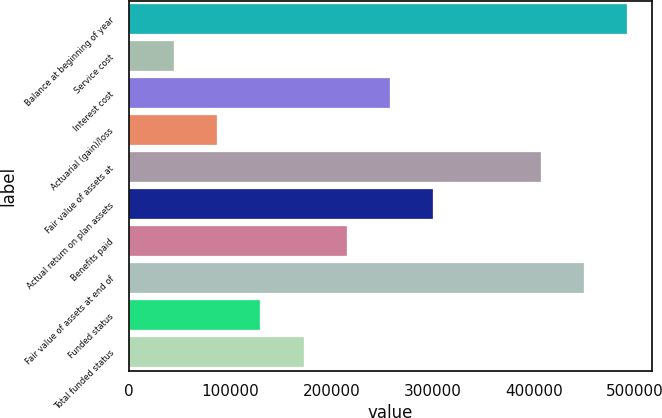Convert chart to OTSL. <chart><loc_0><loc_0><loc_500><loc_500><bar_chart><fcel>Balance at beginning of year<fcel>Service cost<fcel>Interest cost<fcel>Actuarial (gain)/loss<fcel>Fair value of assets at<fcel>Actual return on plan assets<fcel>Benefits paid<fcel>Fair value of assets at end of<fcel>Funded status<fcel>Total funded status<nl><fcel>492365<fcel>44630.2<fcel>257791<fcel>87262.4<fcel>407101<fcel>300423<fcel>215159<fcel>449733<fcel>129895<fcel>172527<nl></chart> 